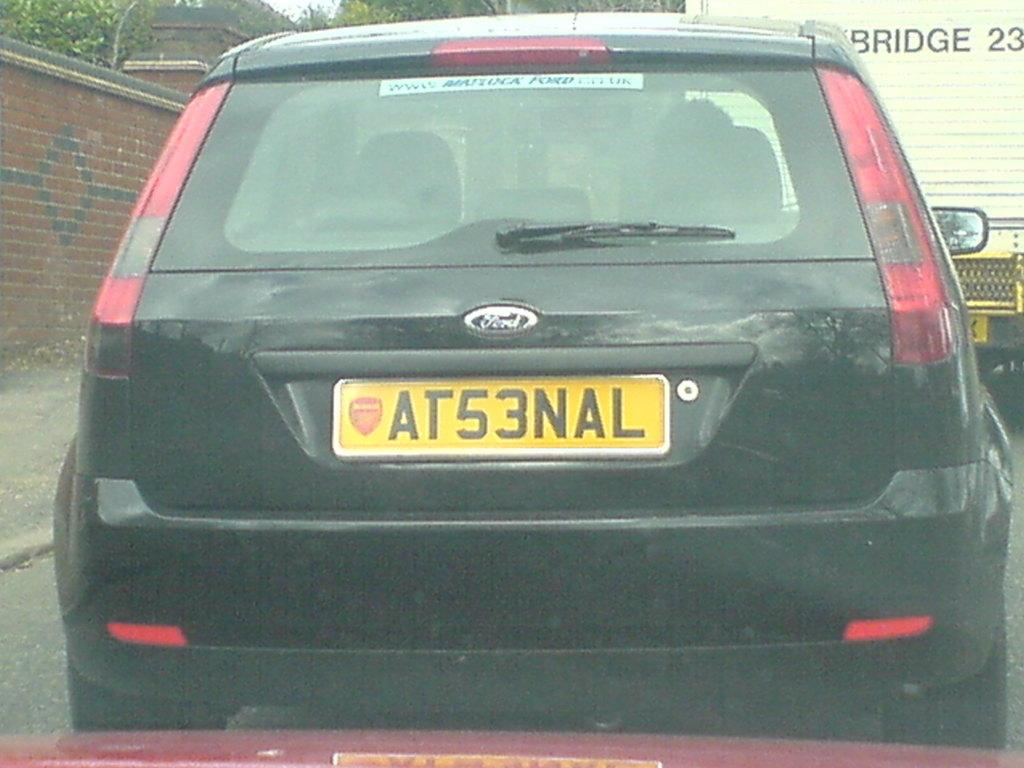<image>
Summarize the visual content of the image. A black ford car with the license plate AT53NAL. 